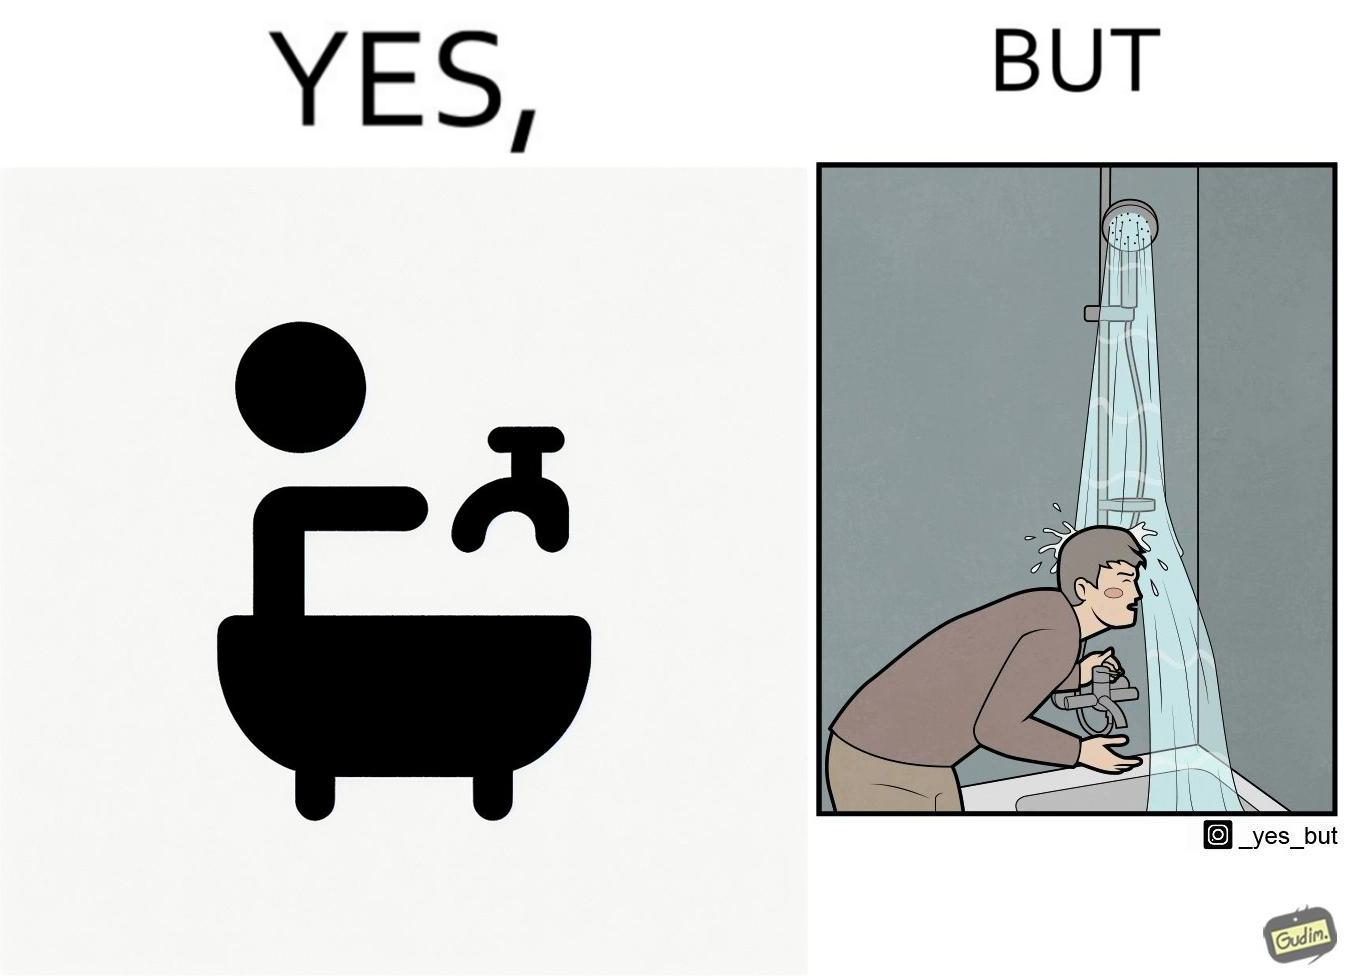What do you see in each half of this image? In the left part of the image: A person operating a tap on top of a bathtub. In the right part of the image: A person operating a tap on top of the bathtub, while water is pouring down on the person from the handheld shower rested upon a holder. 